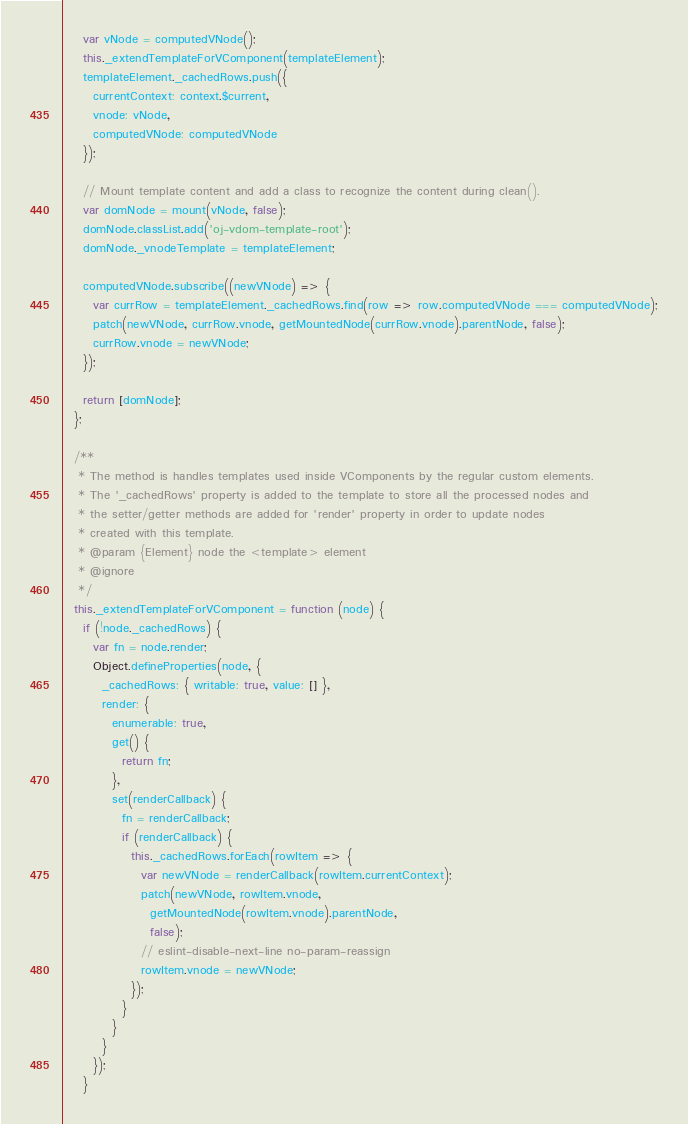<code> <loc_0><loc_0><loc_500><loc_500><_JavaScript_>    var vNode = computedVNode();
    this._extendTemplateForVComponent(templateElement);
    templateElement._cachedRows.push({
      currentContext: context.$current,
      vnode: vNode,
      computedVNode: computedVNode
    });

    // Mount template content and add a class to recognize the content during clean().
    var domNode = mount(vNode, false);
    domNode.classList.add('oj-vdom-template-root');
    domNode._vnodeTemplate = templateElement;

    computedVNode.subscribe((newVNode) => {
      var currRow = templateElement._cachedRows.find(row => row.computedVNode === computedVNode);
      patch(newVNode, currRow.vnode, getMountedNode(currRow.vnode).parentNode, false);
      currRow.vnode = newVNode;
    });

    return [domNode];
  };

  /**
   * The method is handles templates used inside VComponents by the regular custom elements.
   * The '_cachedRows' property is added to the template to store all the processed nodes and
   * the setter/getter methods are added for 'render' property in order to update nodes
   * created with this template.
   * @param {Element} node the <template> element
   * @ignore
   */
  this._extendTemplateForVComponent = function (node) {
    if (!node._cachedRows) {
      var fn = node.render;
      Object.defineProperties(node, {
        _cachedRows: { writable: true, value: [] },
        render: {
          enumerable: true,
          get() {
            return fn;
          },
          set(renderCallback) {
            fn = renderCallback;
            if (renderCallback) {
              this._cachedRows.forEach(rowItem => {
                var newVNode = renderCallback(rowItem.currentContext);
                patch(newVNode, rowItem.vnode,
                  getMountedNode(rowItem.vnode).parentNode,
                  false);
                // eslint-disable-next-line no-param-reassign
                rowItem.vnode = newVNode;
              });
            }
          }
        }
      });
    }</code> 